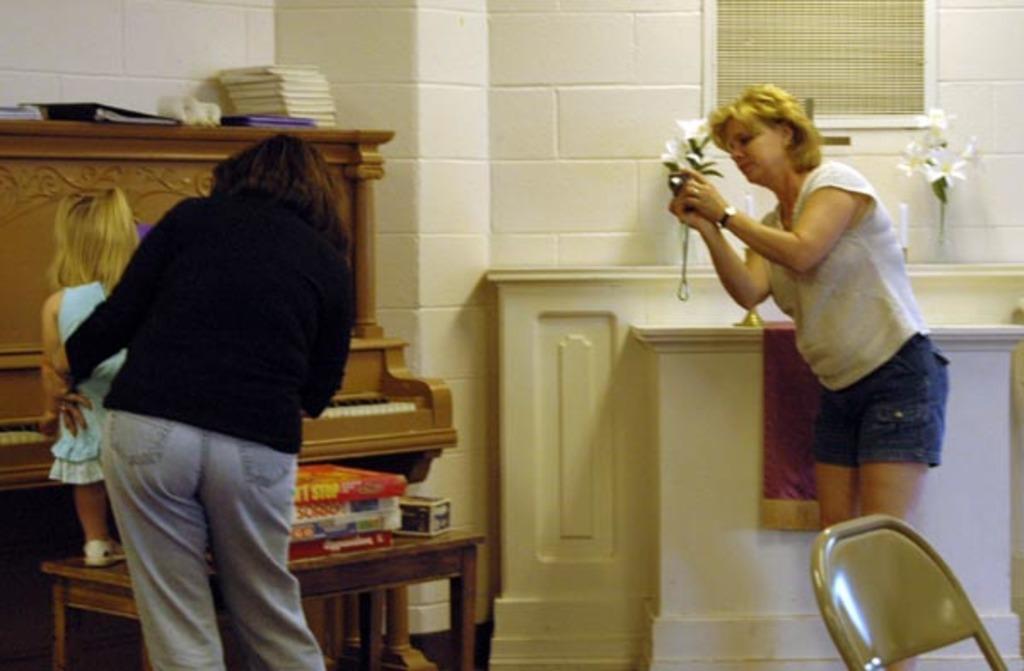In one or two sentences, can you explain what this image depicts? In this, there are three people. Two are women and a girl. One of them is taking photo with a camera in her hand. The other is holding the girl. And the girl is standing on a table. The girl is playing piano in front of her. The room is painted white. There are flower vases. Beside the woman there is chair at corner of the image. 